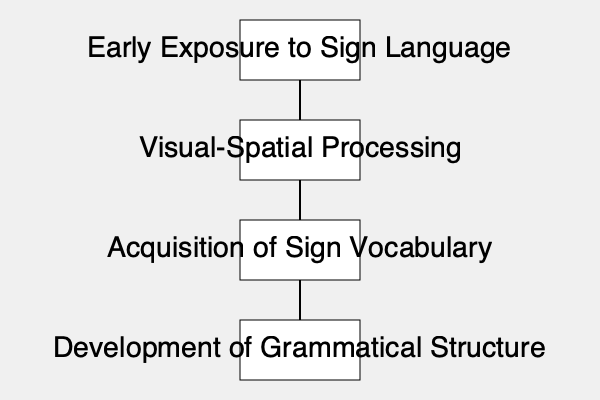According to the flowchart, which step immediately follows the "Visual-Spatial Processing" stage in the language acquisition process for deaf children? To answer this question, we need to follow the steps in the flowchart:

1. The flowchart begins with "Early Exposure to Sign Language" at the top.
2. This leads to "Visual-Spatial Processing," which is the second stage.
3. After "Visual-Spatial Processing," we can see an arrow pointing downwards to the next stage.
4. The stage that immediately follows "Visual-Spatial Processing" is "Acquisition of Sign Vocabulary."
5. The final stage in the flowchart is "Development of Grammatical Structure."

Therefore, based on the information provided in the flowchart, the step that immediately follows the "Visual-Spatial Processing" stage in the language acquisition process for deaf children is the "Acquisition of Sign Vocabulary."
Answer: Acquisition of Sign Vocabulary 